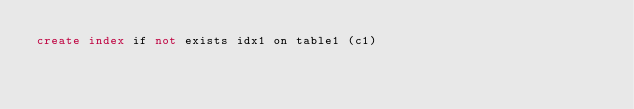Convert code to text. <code><loc_0><loc_0><loc_500><loc_500><_SQL_>create index if not exists idx1 on table1 (c1)</code> 